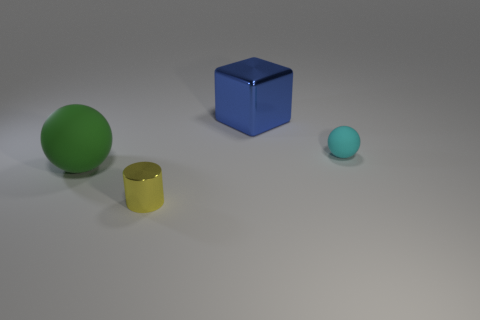Are there an equal number of yellow things that are in front of the tiny cylinder and matte cylinders?
Your response must be concise. Yes. Does the green matte object have the same size as the blue thing?
Give a very brief answer. Yes. What color is the thing that is both to the right of the tiny metallic thing and in front of the large metallic thing?
Your answer should be very brief. Cyan. What is the large thing behind the sphere that is left of the small metal thing made of?
Give a very brief answer. Metal. The other cyan rubber object that is the same shape as the large rubber thing is what size?
Give a very brief answer. Small. There is a object that is in front of the big green thing; is its color the same as the small rubber ball?
Ensure brevity in your answer.  No. Is the number of cyan matte objects less than the number of red shiny spheres?
Give a very brief answer. No. What number of other objects are the same color as the large ball?
Your response must be concise. 0. Do the sphere on the left side of the metallic cylinder and the cube have the same material?
Offer a terse response. No. What material is the small yellow cylinder that is in front of the small cyan rubber ball?
Offer a very short reply. Metal. 